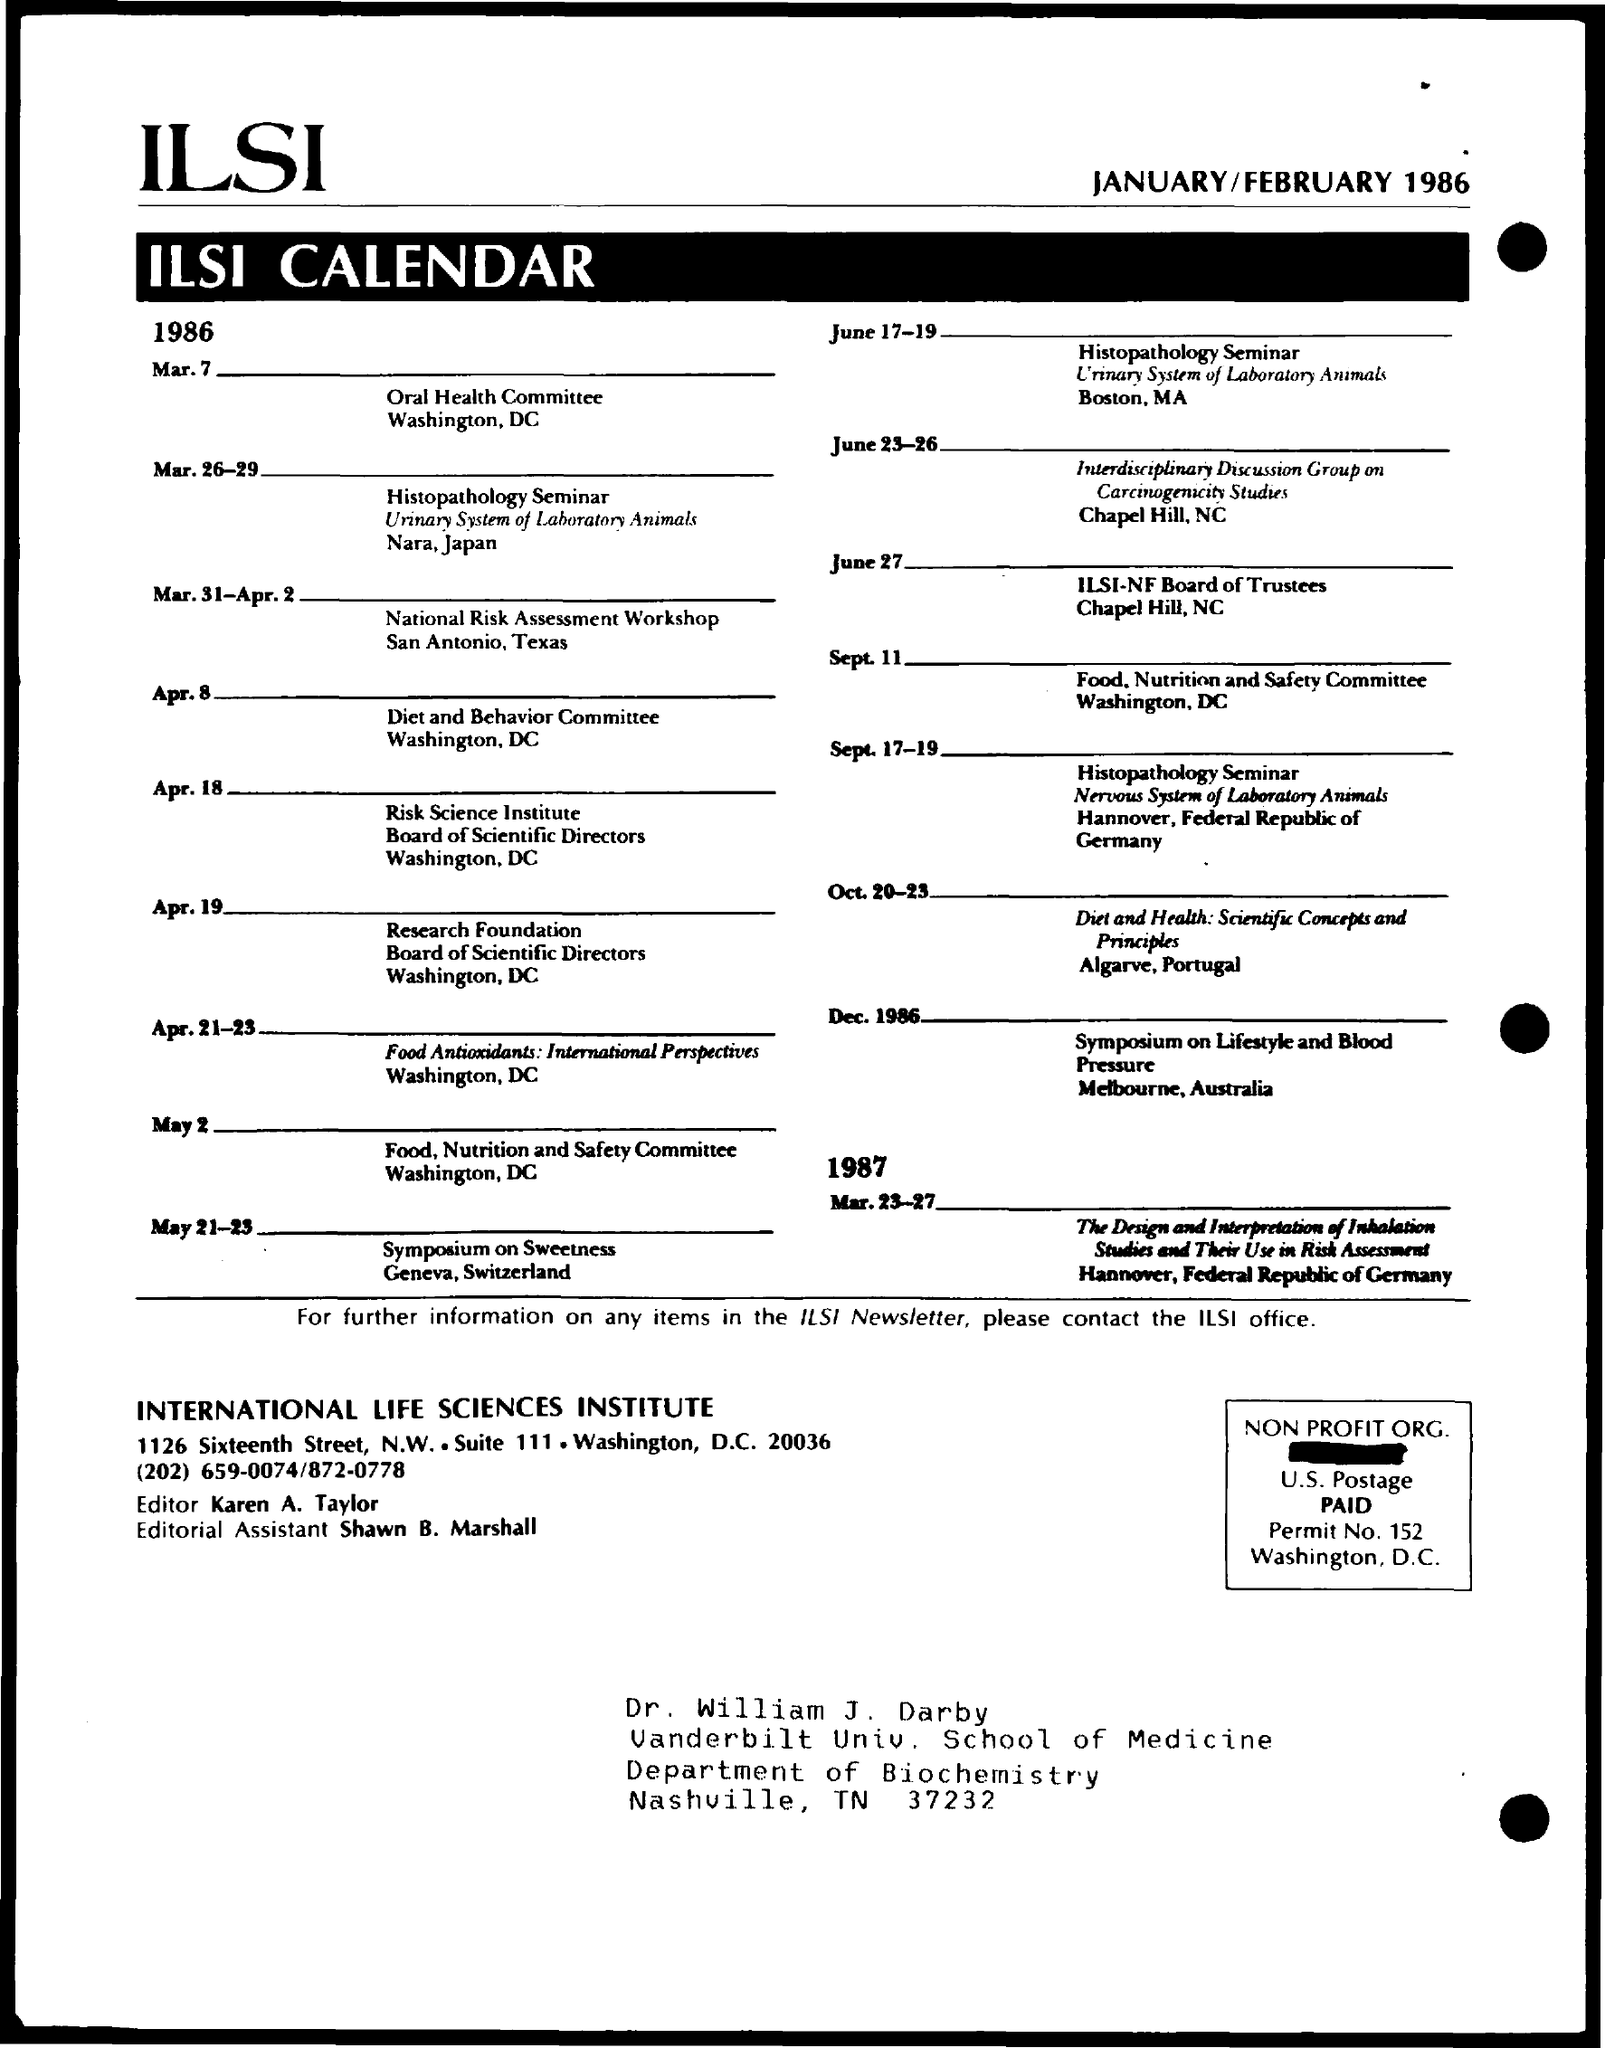List a handful of essential elements in this visual. The first title in the document is 'ilsi..'. The second title in the document is 'ILSI Calendar.' The permit number is 152. Karen A. Taylor is the editor. The editorial assistant is Shawn B. Marshall. 